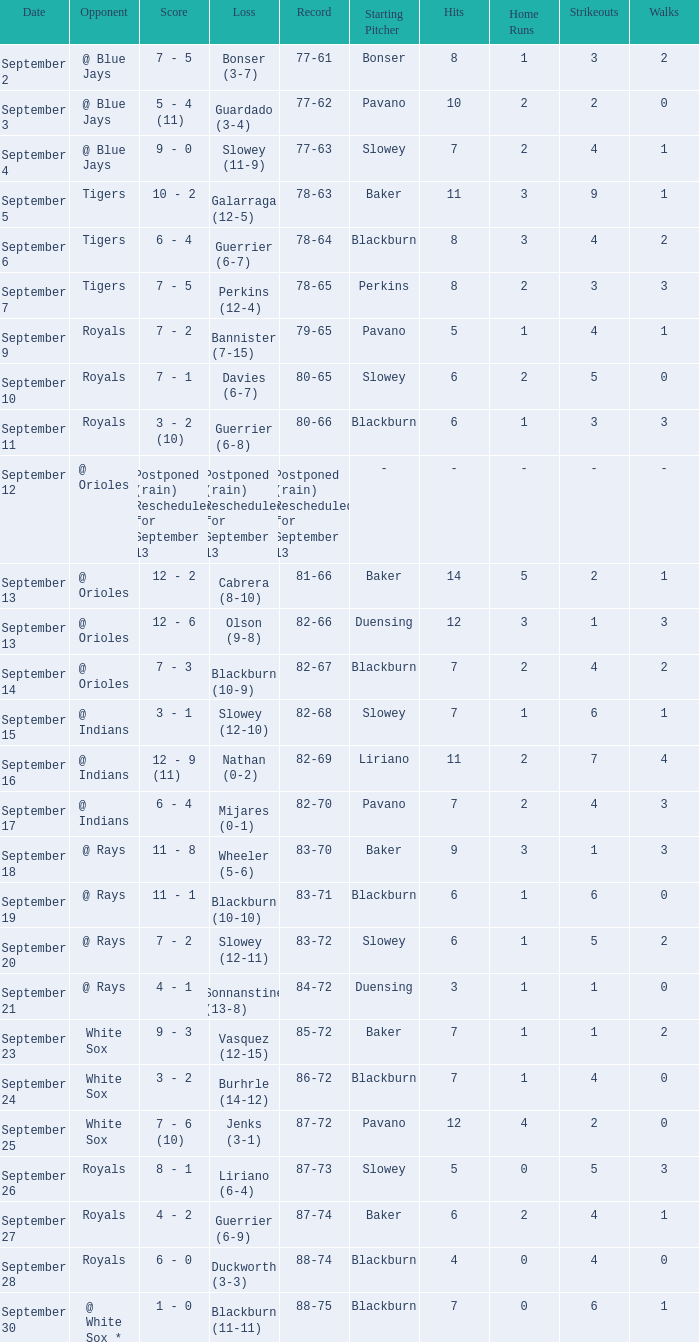What score has the opponent of tigers and a record of 78-64? 6 - 4. 